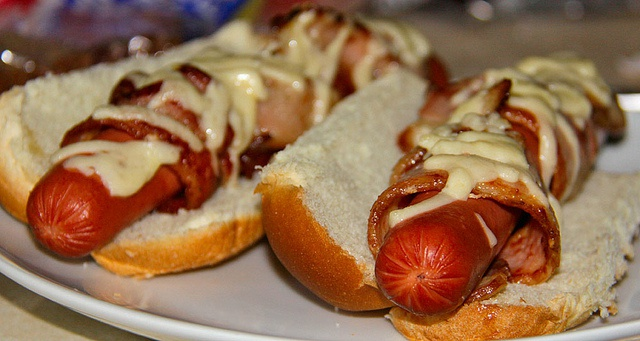Describe the objects in this image and their specific colors. I can see a hot dog in brown, tan, and maroon tones in this image. 